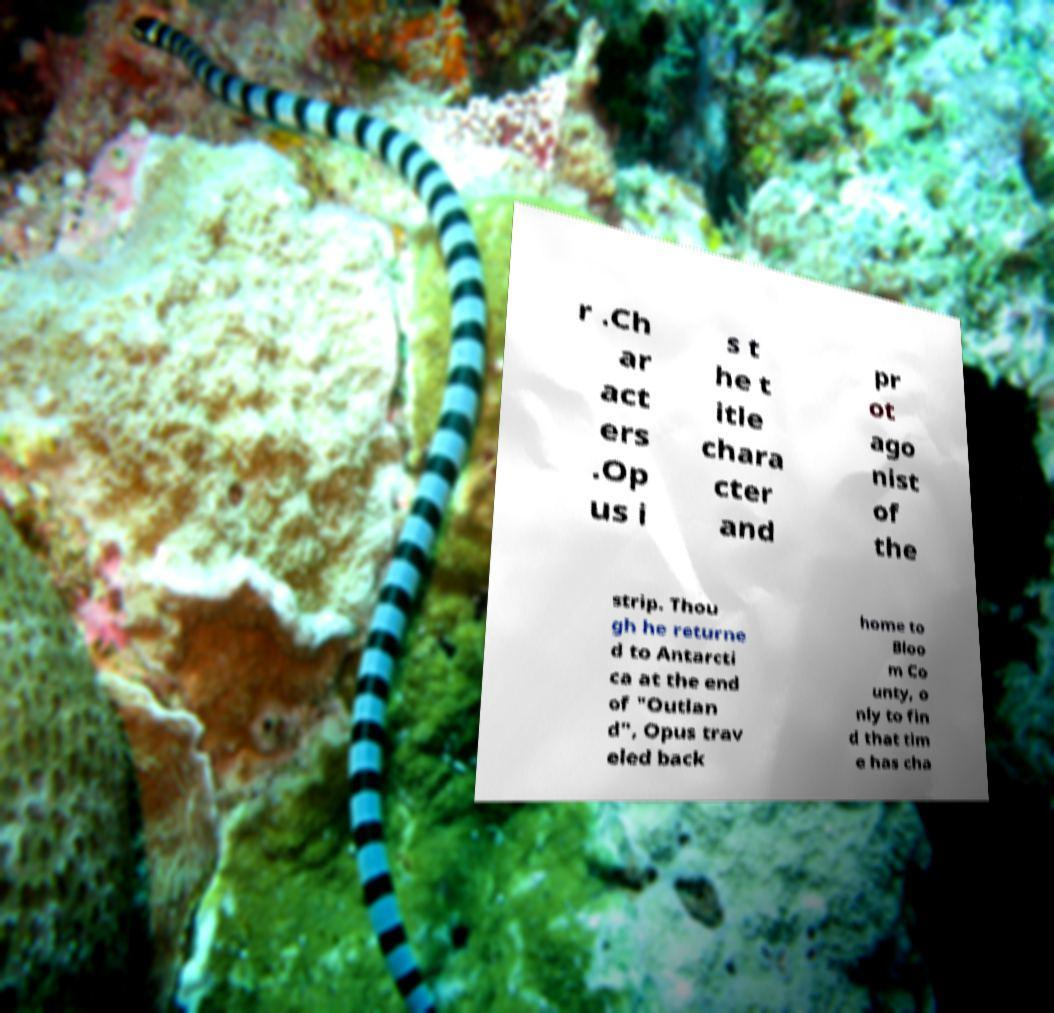Could you extract and type out the text from this image? r .Ch ar act ers .Op us i s t he t itle chara cter and pr ot ago nist of the strip. Thou gh he returne d to Antarcti ca at the end of "Outlan d", Opus trav eled back home to Bloo m Co unty, o nly to fin d that tim e has cha 